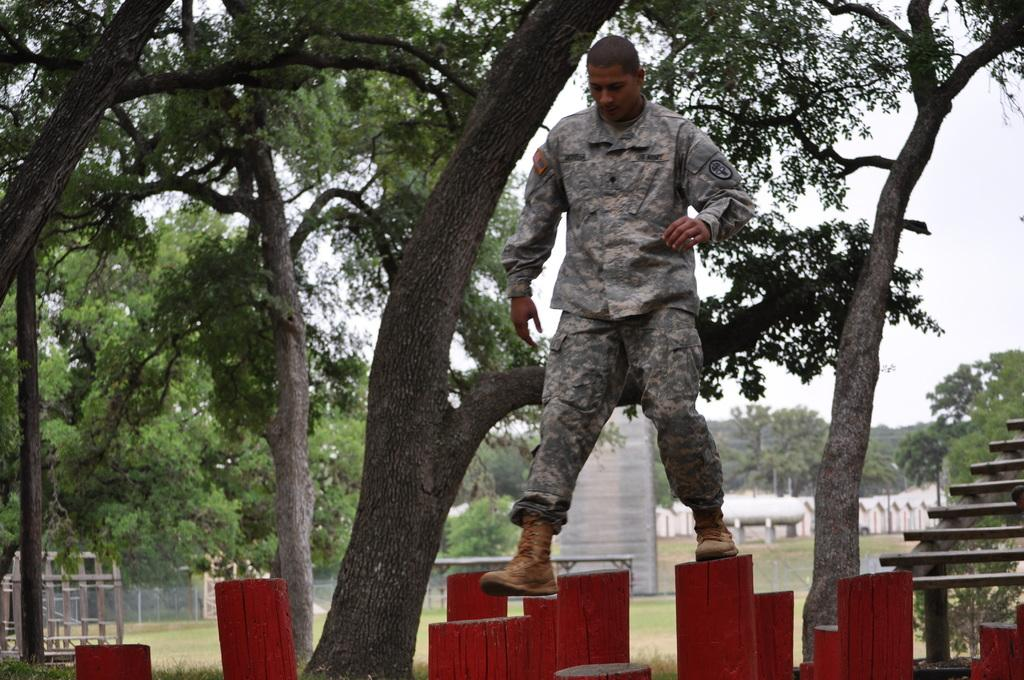What is the main action being performed by the person in the image? The person is walking in the image. What is unique about the surface the person is walking on? The person is walking on red color poles. What type of natural elements can be seen in the image? There are trees in the image. What architectural feature is present on the right side of the image? There are steps on the right side of the image. What can be seen in the background of the image? There are trees and the sky visible in the background of the image. What book is the maid reading in the image? There is no maid or book present in the image. What type of error can be seen in the image? There is no error visible in the image. 